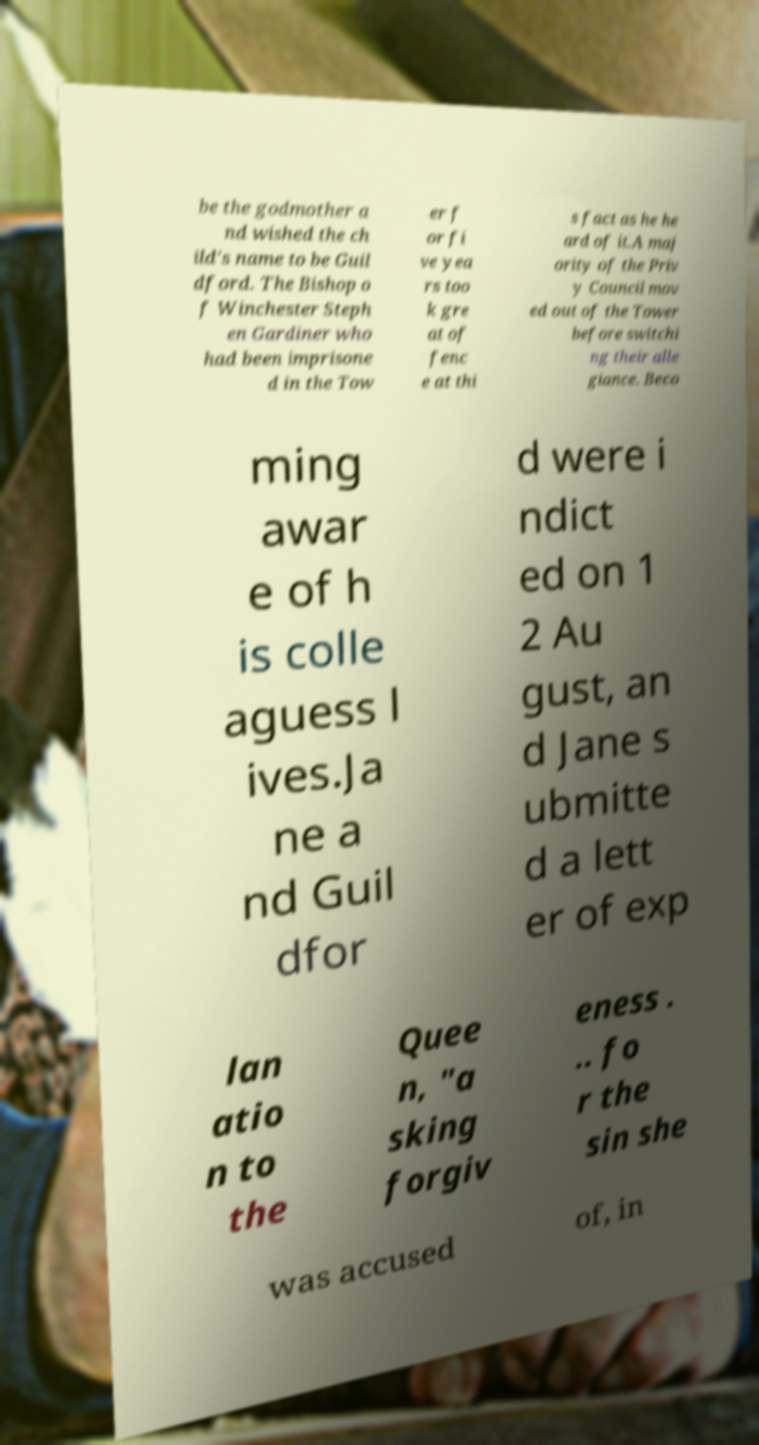Please identify and transcribe the text found in this image. be the godmother a nd wished the ch ild's name to be Guil dford. The Bishop o f Winchester Steph en Gardiner who had been imprisone d in the Tow er f or fi ve yea rs too k gre at of fenc e at thi s fact as he he ard of it.A maj ority of the Priv y Council mov ed out of the Tower before switchi ng their alle giance. Beco ming awar e of h is colle aguess l ives.Ja ne a nd Guil dfor d were i ndict ed on 1 2 Au gust, an d Jane s ubmitte d a lett er of exp lan atio n to the Quee n, "a sking forgiv eness . .. fo r the sin she was accused of, in 